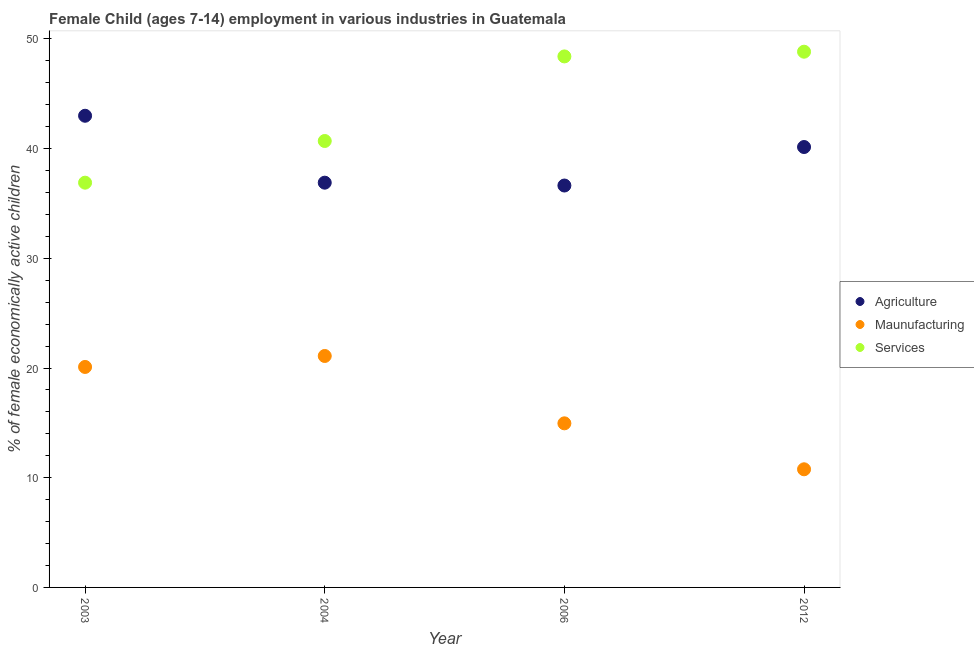What is the percentage of economically active children in services in 2012?
Give a very brief answer. 48.84. Across all years, what is the maximum percentage of economically active children in services?
Provide a succinct answer. 48.84. Across all years, what is the minimum percentage of economically active children in agriculture?
Your answer should be compact. 36.64. What is the total percentage of economically active children in manufacturing in the graph?
Offer a very short reply. 66.93. What is the difference between the percentage of economically active children in manufacturing in 2003 and that in 2004?
Your answer should be very brief. -1. What is the difference between the percentage of economically active children in services in 2012 and the percentage of economically active children in manufacturing in 2004?
Offer a terse response. 27.74. What is the average percentage of economically active children in manufacturing per year?
Keep it short and to the point. 16.73. In the year 2004, what is the difference between the percentage of economically active children in services and percentage of economically active children in manufacturing?
Offer a terse response. 19.6. What is the ratio of the percentage of economically active children in agriculture in 2003 to that in 2004?
Make the answer very short. 1.17. What is the difference between the highest and the second highest percentage of economically active children in manufacturing?
Your answer should be compact. 1. What is the difference between the highest and the lowest percentage of economically active children in agriculture?
Your answer should be compact. 6.36. In how many years, is the percentage of economically active children in manufacturing greater than the average percentage of economically active children in manufacturing taken over all years?
Give a very brief answer. 2. Is the sum of the percentage of economically active children in manufacturing in 2004 and 2006 greater than the maximum percentage of economically active children in services across all years?
Ensure brevity in your answer.  No. Is the percentage of economically active children in services strictly greater than the percentage of economically active children in agriculture over the years?
Make the answer very short. No. Is the percentage of economically active children in agriculture strictly less than the percentage of economically active children in manufacturing over the years?
Provide a succinct answer. No. How many legend labels are there?
Keep it short and to the point. 3. What is the title of the graph?
Ensure brevity in your answer.  Female Child (ages 7-14) employment in various industries in Guatemala. Does "Transport services" appear as one of the legend labels in the graph?
Keep it short and to the point. No. What is the label or title of the X-axis?
Keep it short and to the point. Year. What is the label or title of the Y-axis?
Offer a very short reply. % of female economically active children. What is the % of female economically active children in Agriculture in 2003?
Make the answer very short. 43. What is the % of female economically active children in Maunufacturing in 2003?
Your answer should be compact. 20.1. What is the % of female economically active children of Services in 2003?
Keep it short and to the point. 36.9. What is the % of female economically active children in Agriculture in 2004?
Provide a short and direct response. 36.9. What is the % of female economically active children of Maunufacturing in 2004?
Provide a short and direct response. 21.1. What is the % of female economically active children in Services in 2004?
Your response must be concise. 40.7. What is the % of female economically active children in Agriculture in 2006?
Provide a succinct answer. 36.64. What is the % of female economically active children of Maunufacturing in 2006?
Your answer should be very brief. 14.96. What is the % of female economically active children in Services in 2006?
Make the answer very short. 48.41. What is the % of female economically active children in Agriculture in 2012?
Provide a succinct answer. 40.15. What is the % of female economically active children in Maunufacturing in 2012?
Provide a short and direct response. 10.77. What is the % of female economically active children of Services in 2012?
Your answer should be very brief. 48.84. Across all years, what is the maximum % of female economically active children in Maunufacturing?
Your response must be concise. 21.1. Across all years, what is the maximum % of female economically active children of Services?
Your response must be concise. 48.84. Across all years, what is the minimum % of female economically active children in Agriculture?
Offer a terse response. 36.64. Across all years, what is the minimum % of female economically active children in Maunufacturing?
Make the answer very short. 10.77. Across all years, what is the minimum % of female economically active children of Services?
Keep it short and to the point. 36.9. What is the total % of female economically active children in Agriculture in the graph?
Offer a terse response. 156.69. What is the total % of female economically active children of Maunufacturing in the graph?
Offer a very short reply. 66.93. What is the total % of female economically active children of Services in the graph?
Offer a terse response. 174.85. What is the difference between the % of female economically active children in Agriculture in 2003 and that in 2006?
Offer a very short reply. 6.36. What is the difference between the % of female economically active children of Maunufacturing in 2003 and that in 2006?
Keep it short and to the point. 5.14. What is the difference between the % of female economically active children of Services in 2003 and that in 2006?
Keep it short and to the point. -11.51. What is the difference between the % of female economically active children of Agriculture in 2003 and that in 2012?
Your response must be concise. 2.85. What is the difference between the % of female economically active children of Maunufacturing in 2003 and that in 2012?
Ensure brevity in your answer.  9.33. What is the difference between the % of female economically active children of Services in 2003 and that in 2012?
Make the answer very short. -11.94. What is the difference between the % of female economically active children of Agriculture in 2004 and that in 2006?
Your answer should be compact. 0.26. What is the difference between the % of female economically active children of Maunufacturing in 2004 and that in 2006?
Your response must be concise. 6.14. What is the difference between the % of female economically active children in Services in 2004 and that in 2006?
Give a very brief answer. -7.71. What is the difference between the % of female economically active children of Agriculture in 2004 and that in 2012?
Give a very brief answer. -3.25. What is the difference between the % of female economically active children in Maunufacturing in 2004 and that in 2012?
Make the answer very short. 10.33. What is the difference between the % of female economically active children of Services in 2004 and that in 2012?
Your answer should be very brief. -8.14. What is the difference between the % of female economically active children of Agriculture in 2006 and that in 2012?
Provide a short and direct response. -3.51. What is the difference between the % of female economically active children of Maunufacturing in 2006 and that in 2012?
Provide a short and direct response. 4.19. What is the difference between the % of female economically active children in Services in 2006 and that in 2012?
Give a very brief answer. -0.43. What is the difference between the % of female economically active children of Agriculture in 2003 and the % of female economically active children of Maunufacturing in 2004?
Ensure brevity in your answer.  21.9. What is the difference between the % of female economically active children of Agriculture in 2003 and the % of female economically active children of Services in 2004?
Make the answer very short. 2.3. What is the difference between the % of female economically active children of Maunufacturing in 2003 and the % of female economically active children of Services in 2004?
Keep it short and to the point. -20.6. What is the difference between the % of female economically active children in Agriculture in 2003 and the % of female economically active children in Maunufacturing in 2006?
Keep it short and to the point. 28.04. What is the difference between the % of female economically active children in Agriculture in 2003 and the % of female economically active children in Services in 2006?
Ensure brevity in your answer.  -5.41. What is the difference between the % of female economically active children in Maunufacturing in 2003 and the % of female economically active children in Services in 2006?
Keep it short and to the point. -28.31. What is the difference between the % of female economically active children in Agriculture in 2003 and the % of female economically active children in Maunufacturing in 2012?
Your answer should be very brief. 32.23. What is the difference between the % of female economically active children in Agriculture in 2003 and the % of female economically active children in Services in 2012?
Your response must be concise. -5.84. What is the difference between the % of female economically active children of Maunufacturing in 2003 and the % of female economically active children of Services in 2012?
Your answer should be compact. -28.74. What is the difference between the % of female economically active children in Agriculture in 2004 and the % of female economically active children in Maunufacturing in 2006?
Provide a succinct answer. 21.94. What is the difference between the % of female economically active children of Agriculture in 2004 and the % of female economically active children of Services in 2006?
Ensure brevity in your answer.  -11.51. What is the difference between the % of female economically active children in Maunufacturing in 2004 and the % of female economically active children in Services in 2006?
Provide a succinct answer. -27.31. What is the difference between the % of female economically active children in Agriculture in 2004 and the % of female economically active children in Maunufacturing in 2012?
Your answer should be very brief. 26.13. What is the difference between the % of female economically active children in Agriculture in 2004 and the % of female economically active children in Services in 2012?
Offer a terse response. -11.94. What is the difference between the % of female economically active children in Maunufacturing in 2004 and the % of female economically active children in Services in 2012?
Offer a very short reply. -27.74. What is the difference between the % of female economically active children of Agriculture in 2006 and the % of female economically active children of Maunufacturing in 2012?
Offer a terse response. 25.87. What is the difference between the % of female economically active children of Maunufacturing in 2006 and the % of female economically active children of Services in 2012?
Make the answer very short. -33.88. What is the average % of female economically active children of Agriculture per year?
Give a very brief answer. 39.17. What is the average % of female economically active children in Maunufacturing per year?
Offer a very short reply. 16.73. What is the average % of female economically active children in Services per year?
Offer a terse response. 43.71. In the year 2003, what is the difference between the % of female economically active children in Agriculture and % of female economically active children in Maunufacturing?
Provide a succinct answer. 22.9. In the year 2003, what is the difference between the % of female economically active children in Maunufacturing and % of female economically active children in Services?
Ensure brevity in your answer.  -16.8. In the year 2004, what is the difference between the % of female economically active children in Maunufacturing and % of female economically active children in Services?
Give a very brief answer. -19.6. In the year 2006, what is the difference between the % of female economically active children in Agriculture and % of female economically active children in Maunufacturing?
Your answer should be very brief. 21.68. In the year 2006, what is the difference between the % of female economically active children in Agriculture and % of female economically active children in Services?
Your answer should be compact. -11.77. In the year 2006, what is the difference between the % of female economically active children of Maunufacturing and % of female economically active children of Services?
Make the answer very short. -33.45. In the year 2012, what is the difference between the % of female economically active children in Agriculture and % of female economically active children in Maunufacturing?
Keep it short and to the point. 29.38. In the year 2012, what is the difference between the % of female economically active children of Agriculture and % of female economically active children of Services?
Your answer should be compact. -8.69. In the year 2012, what is the difference between the % of female economically active children in Maunufacturing and % of female economically active children in Services?
Offer a very short reply. -38.07. What is the ratio of the % of female economically active children in Agriculture in 2003 to that in 2004?
Offer a terse response. 1.17. What is the ratio of the % of female economically active children of Maunufacturing in 2003 to that in 2004?
Offer a very short reply. 0.95. What is the ratio of the % of female economically active children in Services in 2003 to that in 2004?
Ensure brevity in your answer.  0.91. What is the ratio of the % of female economically active children in Agriculture in 2003 to that in 2006?
Make the answer very short. 1.17. What is the ratio of the % of female economically active children in Maunufacturing in 2003 to that in 2006?
Offer a terse response. 1.34. What is the ratio of the % of female economically active children in Services in 2003 to that in 2006?
Your answer should be compact. 0.76. What is the ratio of the % of female economically active children in Agriculture in 2003 to that in 2012?
Keep it short and to the point. 1.07. What is the ratio of the % of female economically active children of Maunufacturing in 2003 to that in 2012?
Provide a short and direct response. 1.87. What is the ratio of the % of female economically active children of Services in 2003 to that in 2012?
Ensure brevity in your answer.  0.76. What is the ratio of the % of female economically active children of Agriculture in 2004 to that in 2006?
Your response must be concise. 1.01. What is the ratio of the % of female economically active children of Maunufacturing in 2004 to that in 2006?
Your response must be concise. 1.41. What is the ratio of the % of female economically active children of Services in 2004 to that in 2006?
Provide a succinct answer. 0.84. What is the ratio of the % of female economically active children of Agriculture in 2004 to that in 2012?
Make the answer very short. 0.92. What is the ratio of the % of female economically active children of Maunufacturing in 2004 to that in 2012?
Your answer should be compact. 1.96. What is the ratio of the % of female economically active children in Services in 2004 to that in 2012?
Provide a succinct answer. 0.83. What is the ratio of the % of female economically active children of Agriculture in 2006 to that in 2012?
Provide a short and direct response. 0.91. What is the ratio of the % of female economically active children of Maunufacturing in 2006 to that in 2012?
Offer a terse response. 1.39. What is the ratio of the % of female economically active children of Services in 2006 to that in 2012?
Ensure brevity in your answer.  0.99. What is the difference between the highest and the second highest % of female economically active children of Agriculture?
Keep it short and to the point. 2.85. What is the difference between the highest and the second highest % of female economically active children in Maunufacturing?
Provide a succinct answer. 1. What is the difference between the highest and the second highest % of female economically active children of Services?
Your response must be concise. 0.43. What is the difference between the highest and the lowest % of female economically active children of Agriculture?
Make the answer very short. 6.36. What is the difference between the highest and the lowest % of female economically active children of Maunufacturing?
Your response must be concise. 10.33. What is the difference between the highest and the lowest % of female economically active children in Services?
Give a very brief answer. 11.94. 